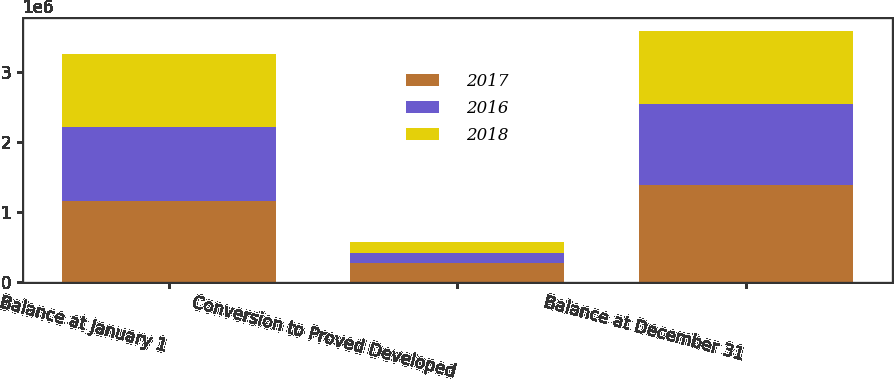Convert chart to OTSL. <chart><loc_0><loc_0><loc_500><loc_500><stacked_bar_chart><ecel><fcel>Balance at January 1<fcel>Conversion to Proved Developed<fcel>Balance at December 31<nl><fcel>2017<fcel>1.16264e+06<fcel>265718<fcel>1.37971e+06<nl><fcel>2016<fcel>1.05303e+06<fcel>152644<fcel>1.16264e+06<nl><fcel>2018<fcel>1.04564e+06<fcel>149210<fcel>1.05303e+06<nl></chart> 